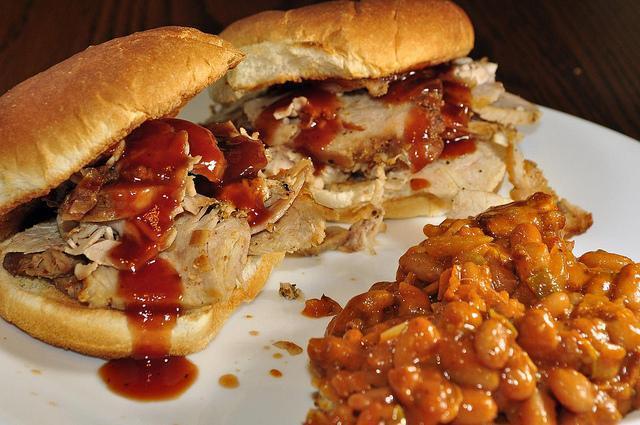How many sandwiches are on the plate?
Give a very brief answer. 2. How many sandwiches can be seen?
Give a very brief answer. 2. How many people are having flowers in their hand?
Give a very brief answer. 0. 